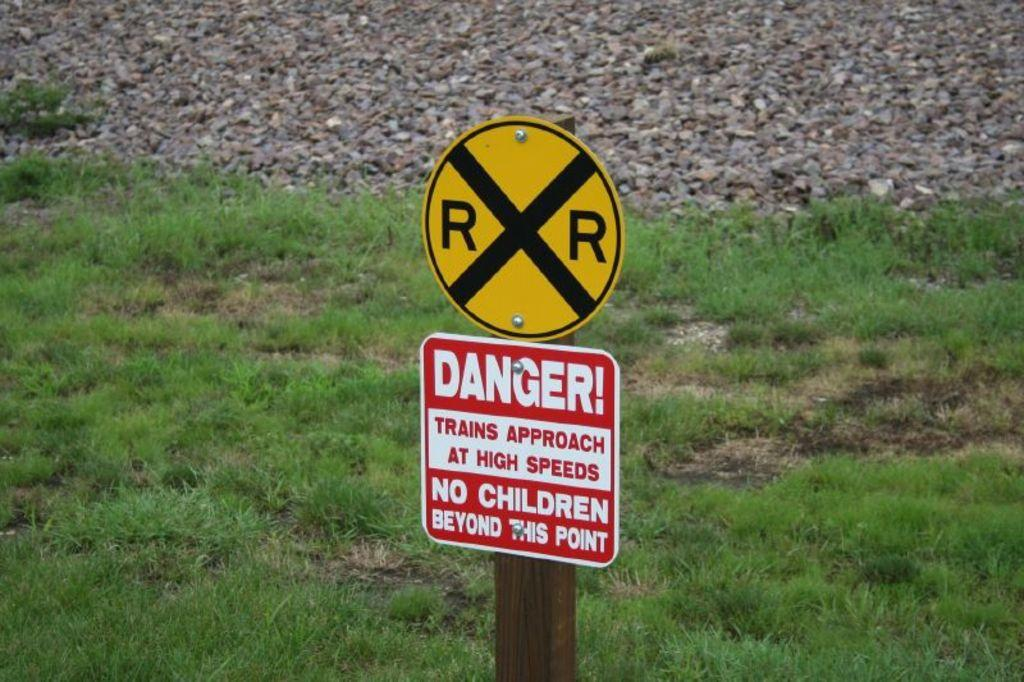<image>
Summarize the visual content of the image. Yellow sign with the letter R on top of a red sign. 